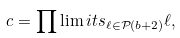Convert formula to latex. <formula><loc_0><loc_0><loc_500><loc_500>c = \prod \lim i t s _ { \ell \in \mathcal { P } ( b + 2 ) } \ell ,</formula> 